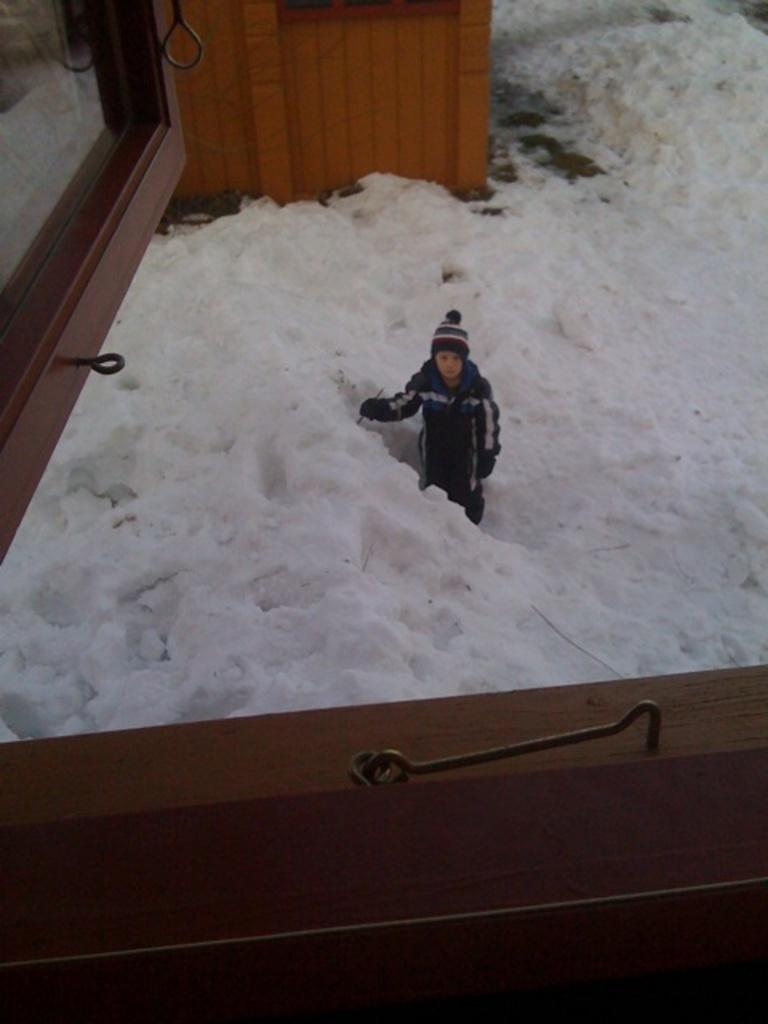What can be seen on the window in the image? There is a hook on the window in the image. What is the condition of the ground in the image? There is snow on the ground in the image. What is the person in the image wearing on their head? The person in the image is wearing a cap. What type of object is at the top of the image? There is a wooden object at the top of the image. What is the rate of the person's hate for pears in the image? There is no indication of the person's feelings towards pears in the image, nor is there any mention of pears. 